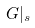Convert formula to latex. <formula><loc_0><loc_0><loc_500><loc_500>G | _ { s }</formula> 